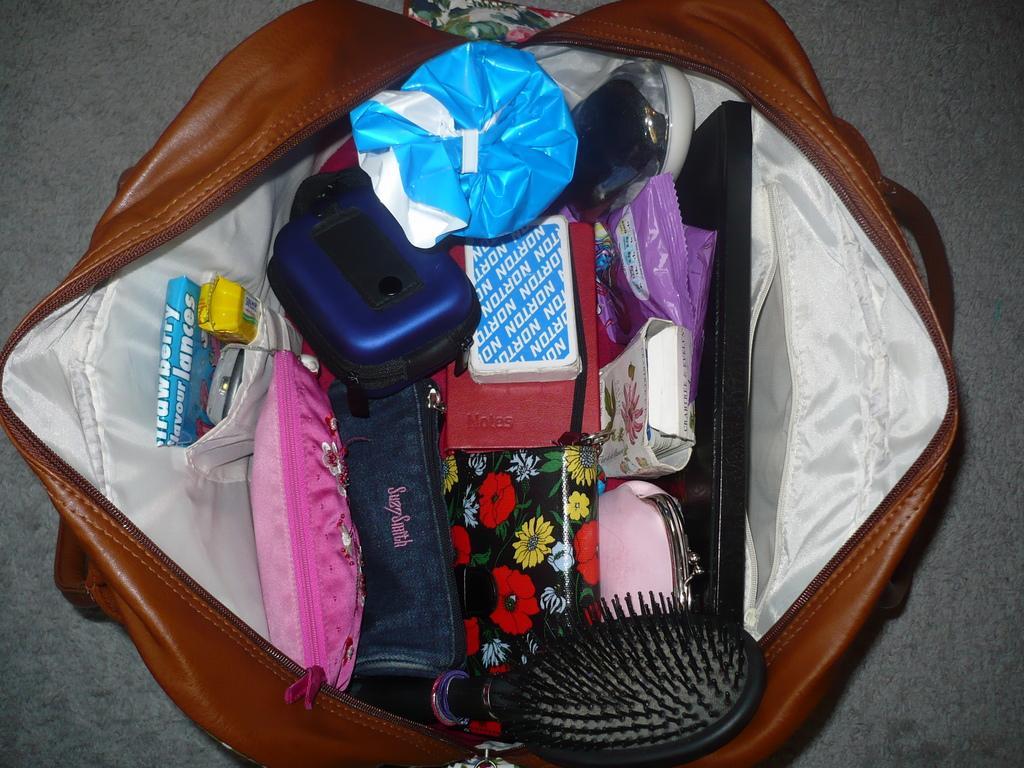Describe this image in one or two sentences. In this brown bag we can able to see toffees, mobile, wallets, box, gift wrap, file, cards and comb. 